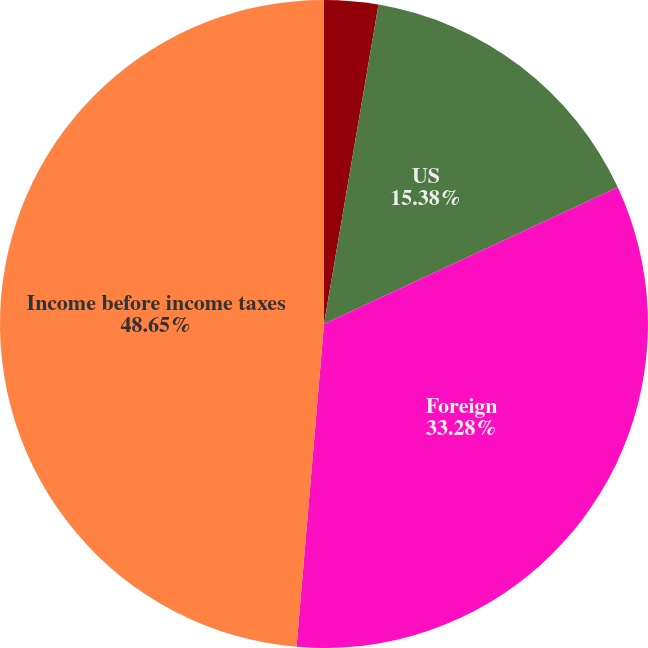Convert chart. <chart><loc_0><loc_0><loc_500><loc_500><pie_chart><fcel>Year Ended June 30<fcel>US<fcel>Foreign<fcel>Income before income taxes<nl><fcel>2.69%<fcel>15.38%<fcel>33.28%<fcel>48.65%<nl></chart> 